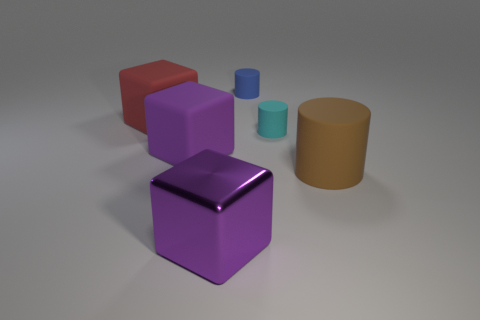Is there any other thing that is the same size as the red rubber block?
Offer a terse response. Yes. There is another large object that is the same color as the big shiny object; what is it made of?
Your response must be concise. Rubber. There is another thing that is the same color as the metallic object; what is its size?
Provide a short and direct response. Large. There is a block in front of the large purple rubber block; what is its size?
Provide a succinct answer. Large. How many other metal objects are the same color as the metal thing?
Ensure brevity in your answer.  0. What number of cylinders are small cyan matte objects or big purple rubber things?
Ensure brevity in your answer.  1. What shape is the matte object that is in front of the cyan matte cylinder and on the left side of the purple shiny cube?
Ensure brevity in your answer.  Cube. Are there any red matte cubes of the same size as the cyan matte cylinder?
Offer a very short reply. No. What number of objects are large blocks that are behind the brown object or cyan rubber cylinders?
Keep it short and to the point. 3. Is the red thing made of the same material as the object that is behind the big red thing?
Your answer should be very brief. Yes. 